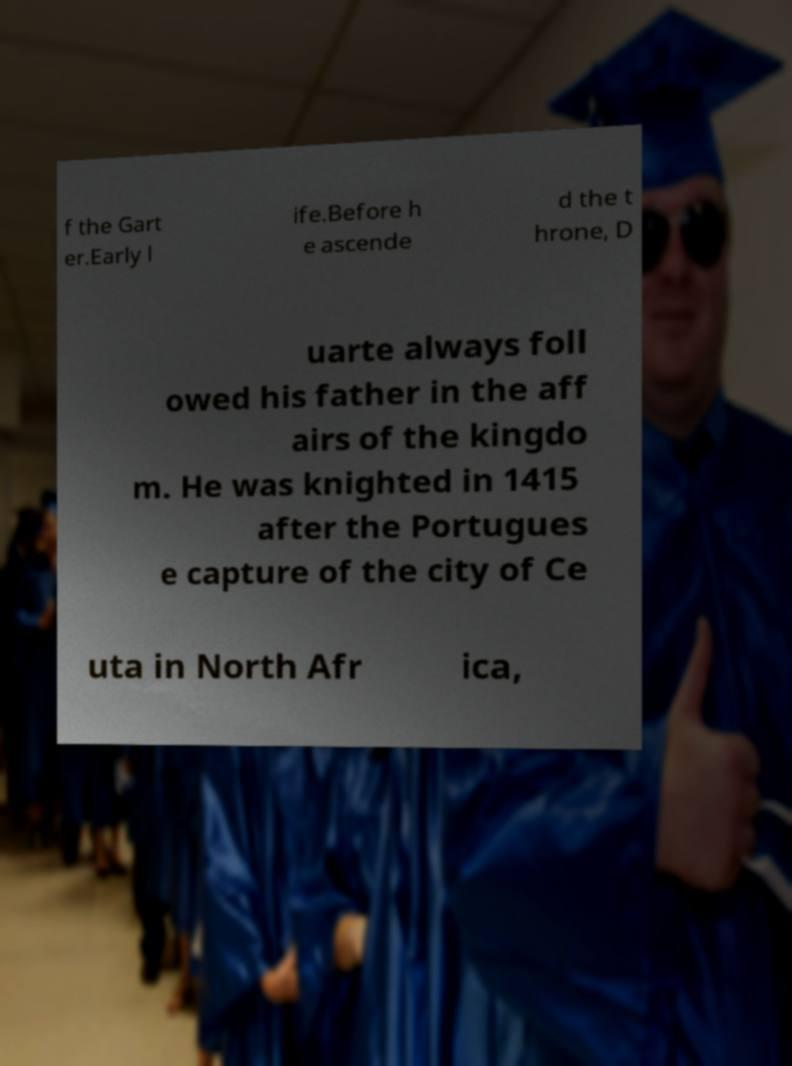For documentation purposes, I need the text within this image transcribed. Could you provide that? f the Gart er.Early l ife.Before h e ascende d the t hrone, D uarte always foll owed his father in the aff airs of the kingdo m. He was knighted in 1415 after the Portugues e capture of the city of Ce uta in North Afr ica, 